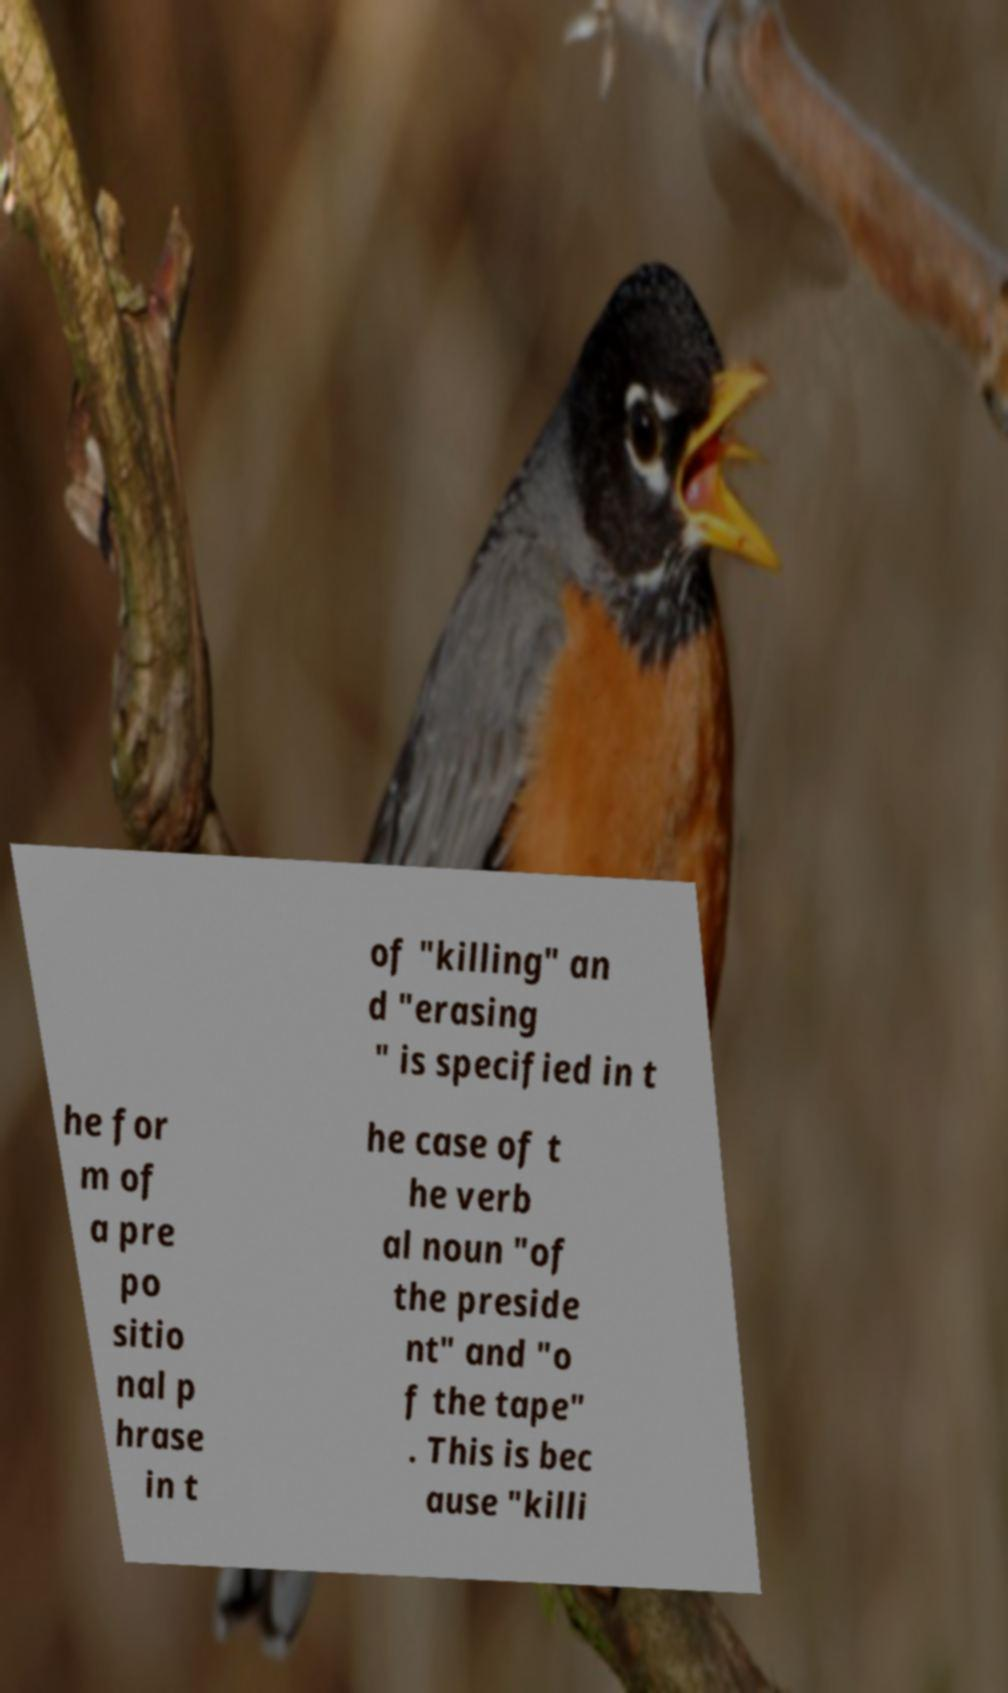For documentation purposes, I need the text within this image transcribed. Could you provide that? of "killing" an d "erasing " is specified in t he for m of a pre po sitio nal p hrase in t he case of t he verb al noun "of the preside nt" and "o f the tape" . This is bec ause "killi 